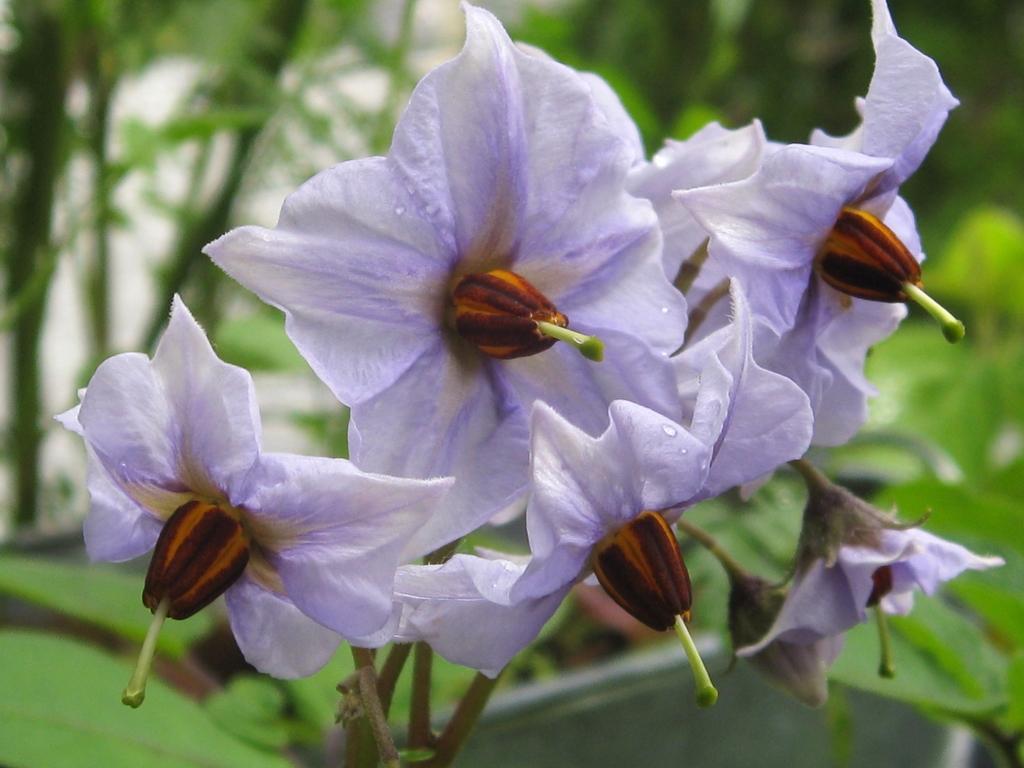Can you describe this image briefly? We can see flowers. In the background it is green. 